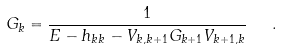Convert formula to latex. <formula><loc_0><loc_0><loc_500><loc_500>G _ { k } = \frac { 1 } { E - h _ { k k } - V _ { k , k + 1 } G _ { k + 1 } V _ { k + 1 , k } } \ \ .</formula> 